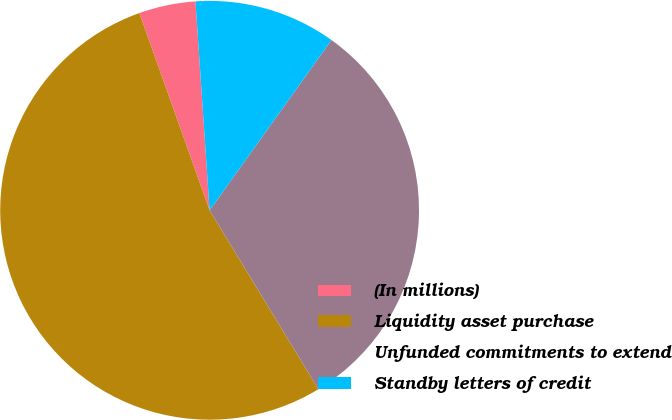Convert chart to OTSL. <chart><loc_0><loc_0><loc_500><loc_500><pie_chart><fcel>(In millions)<fcel>Liquidity asset purchase<fcel>Unfunded commitments to extend<fcel>Standby letters of credit<nl><fcel>4.37%<fcel>53.25%<fcel>31.42%<fcel>10.96%<nl></chart> 